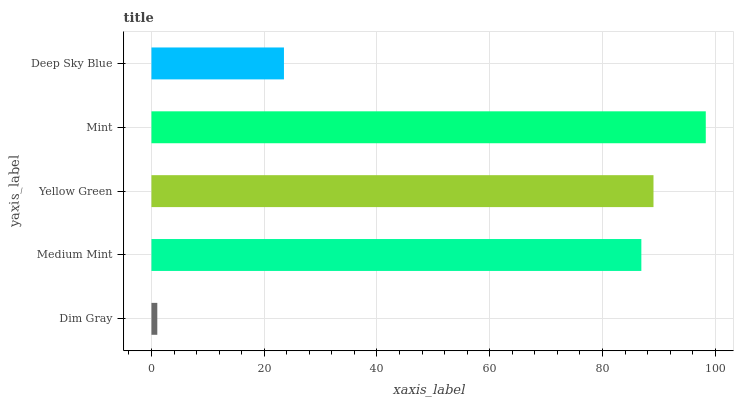Is Dim Gray the minimum?
Answer yes or no. Yes. Is Mint the maximum?
Answer yes or no. Yes. Is Medium Mint the minimum?
Answer yes or no. No. Is Medium Mint the maximum?
Answer yes or no. No. Is Medium Mint greater than Dim Gray?
Answer yes or no. Yes. Is Dim Gray less than Medium Mint?
Answer yes or no. Yes. Is Dim Gray greater than Medium Mint?
Answer yes or no. No. Is Medium Mint less than Dim Gray?
Answer yes or no. No. Is Medium Mint the high median?
Answer yes or no. Yes. Is Medium Mint the low median?
Answer yes or no. Yes. Is Dim Gray the high median?
Answer yes or no. No. Is Yellow Green the low median?
Answer yes or no. No. 